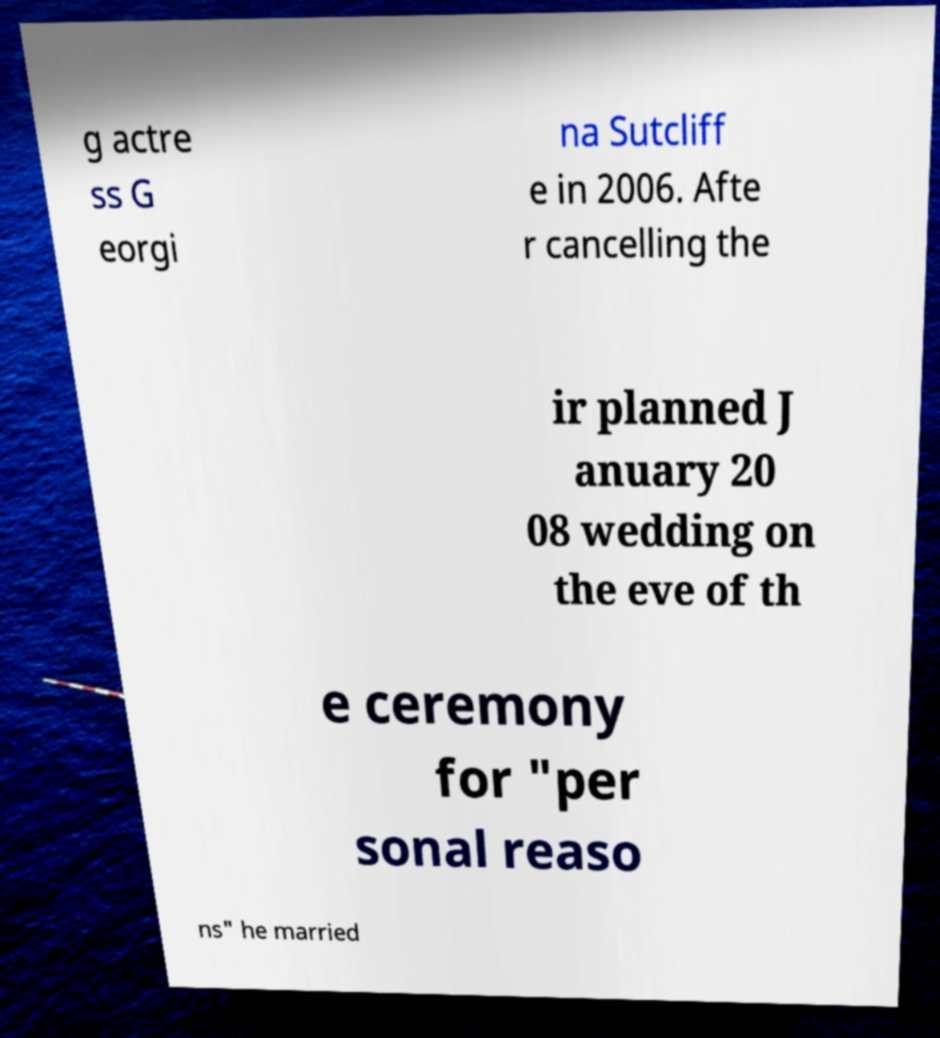Please identify and transcribe the text found in this image. g actre ss G eorgi na Sutcliff e in 2006. Afte r cancelling the ir planned J anuary 20 08 wedding on the eve of th e ceremony for "per sonal reaso ns" he married 